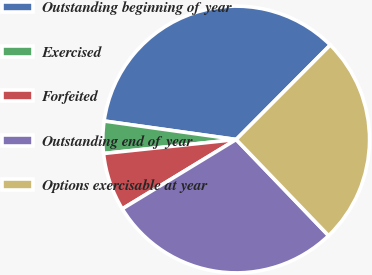Convert chart. <chart><loc_0><loc_0><loc_500><loc_500><pie_chart><fcel>Outstanding beginning of year<fcel>Exercised<fcel>Forfeited<fcel>Outstanding end of year<fcel>Options exercisable at year<nl><fcel>35.25%<fcel>3.89%<fcel>7.03%<fcel>28.48%<fcel>25.35%<nl></chart> 